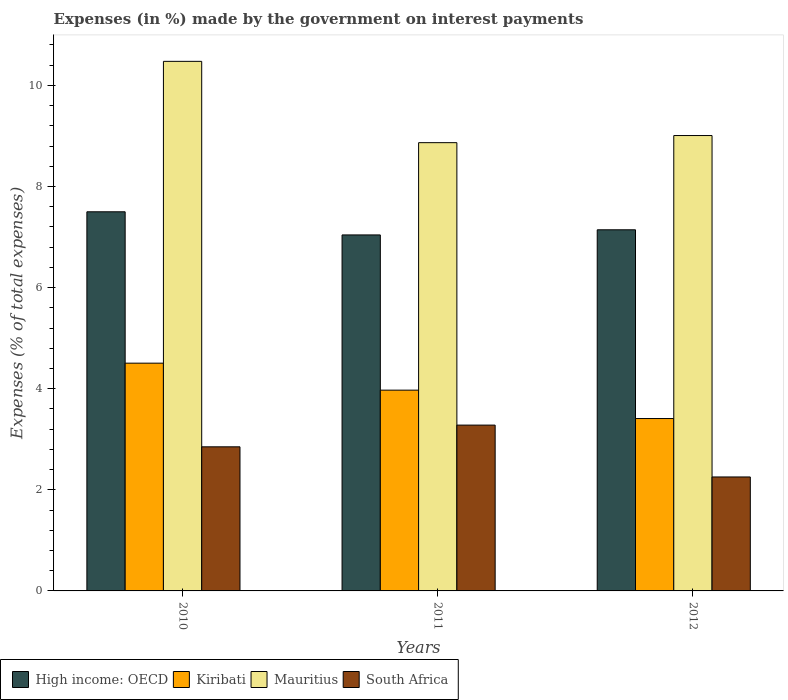What is the label of the 3rd group of bars from the left?
Your response must be concise. 2012. In how many cases, is the number of bars for a given year not equal to the number of legend labels?
Your answer should be very brief. 0. What is the percentage of expenses made by the government on interest payments in Mauritius in 2010?
Offer a very short reply. 10.48. Across all years, what is the maximum percentage of expenses made by the government on interest payments in South Africa?
Offer a very short reply. 3.28. Across all years, what is the minimum percentage of expenses made by the government on interest payments in High income: OECD?
Your answer should be compact. 7.04. In which year was the percentage of expenses made by the government on interest payments in Mauritius maximum?
Provide a short and direct response. 2010. In which year was the percentage of expenses made by the government on interest payments in High income: OECD minimum?
Provide a short and direct response. 2011. What is the total percentage of expenses made by the government on interest payments in Kiribati in the graph?
Keep it short and to the point. 11.89. What is the difference between the percentage of expenses made by the government on interest payments in Kiribati in 2011 and that in 2012?
Your answer should be very brief. 0.56. What is the difference between the percentage of expenses made by the government on interest payments in Mauritius in 2011 and the percentage of expenses made by the government on interest payments in South Africa in 2012?
Provide a succinct answer. 6.61. What is the average percentage of expenses made by the government on interest payments in Mauritius per year?
Your answer should be compact. 9.45. In the year 2012, what is the difference between the percentage of expenses made by the government on interest payments in High income: OECD and percentage of expenses made by the government on interest payments in South Africa?
Make the answer very short. 4.89. What is the ratio of the percentage of expenses made by the government on interest payments in South Africa in 2011 to that in 2012?
Keep it short and to the point. 1.46. What is the difference between the highest and the second highest percentage of expenses made by the government on interest payments in Mauritius?
Offer a very short reply. 1.47. What is the difference between the highest and the lowest percentage of expenses made by the government on interest payments in Mauritius?
Provide a short and direct response. 1.61. In how many years, is the percentage of expenses made by the government on interest payments in Mauritius greater than the average percentage of expenses made by the government on interest payments in Mauritius taken over all years?
Make the answer very short. 1. What does the 4th bar from the left in 2010 represents?
Offer a very short reply. South Africa. What does the 2nd bar from the right in 2012 represents?
Keep it short and to the point. Mauritius. Is it the case that in every year, the sum of the percentage of expenses made by the government on interest payments in Mauritius and percentage of expenses made by the government on interest payments in South Africa is greater than the percentage of expenses made by the government on interest payments in High income: OECD?
Provide a short and direct response. Yes. Are all the bars in the graph horizontal?
Ensure brevity in your answer.  No. Are the values on the major ticks of Y-axis written in scientific E-notation?
Your answer should be compact. No. Does the graph contain any zero values?
Give a very brief answer. No. How many legend labels are there?
Provide a succinct answer. 4. What is the title of the graph?
Offer a very short reply. Expenses (in %) made by the government on interest payments. What is the label or title of the X-axis?
Make the answer very short. Years. What is the label or title of the Y-axis?
Give a very brief answer. Expenses (% of total expenses). What is the Expenses (% of total expenses) of High income: OECD in 2010?
Offer a terse response. 7.5. What is the Expenses (% of total expenses) of Kiribati in 2010?
Keep it short and to the point. 4.51. What is the Expenses (% of total expenses) of Mauritius in 2010?
Provide a short and direct response. 10.48. What is the Expenses (% of total expenses) in South Africa in 2010?
Give a very brief answer. 2.85. What is the Expenses (% of total expenses) in High income: OECD in 2011?
Provide a succinct answer. 7.04. What is the Expenses (% of total expenses) in Kiribati in 2011?
Your answer should be very brief. 3.97. What is the Expenses (% of total expenses) in Mauritius in 2011?
Provide a short and direct response. 8.87. What is the Expenses (% of total expenses) of South Africa in 2011?
Provide a short and direct response. 3.28. What is the Expenses (% of total expenses) in High income: OECD in 2012?
Offer a very short reply. 7.14. What is the Expenses (% of total expenses) of Kiribati in 2012?
Your answer should be very brief. 3.41. What is the Expenses (% of total expenses) of Mauritius in 2012?
Provide a succinct answer. 9.01. What is the Expenses (% of total expenses) of South Africa in 2012?
Your answer should be very brief. 2.25. Across all years, what is the maximum Expenses (% of total expenses) of High income: OECD?
Provide a succinct answer. 7.5. Across all years, what is the maximum Expenses (% of total expenses) in Kiribati?
Give a very brief answer. 4.51. Across all years, what is the maximum Expenses (% of total expenses) in Mauritius?
Give a very brief answer. 10.48. Across all years, what is the maximum Expenses (% of total expenses) in South Africa?
Provide a short and direct response. 3.28. Across all years, what is the minimum Expenses (% of total expenses) of High income: OECD?
Provide a succinct answer. 7.04. Across all years, what is the minimum Expenses (% of total expenses) in Kiribati?
Ensure brevity in your answer.  3.41. Across all years, what is the minimum Expenses (% of total expenses) of Mauritius?
Offer a terse response. 8.87. Across all years, what is the minimum Expenses (% of total expenses) in South Africa?
Ensure brevity in your answer.  2.25. What is the total Expenses (% of total expenses) in High income: OECD in the graph?
Your answer should be very brief. 21.69. What is the total Expenses (% of total expenses) of Kiribati in the graph?
Make the answer very short. 11.89. What is the total Expenses (% of total expenses) of Mauritius in the graph?
Provide a short and direct response. 28.35. What is the total Expenses (% of total expenses) in South Africa in the graph?
Provide a short and direct response. 8.38. What is the difference between the Expenses (% of total expenses) of High income: OECD in 2010 and that in 2011?
Give a very brief answer. 0.46. What is the difference between the Expenses (% of total expenses) in Kiribati in 2010 and that in 2011?
Offer a very short reply. 0.53. What is the difference between the Expenses (% of total expenses) in Mauritius in 2010 and that in 2011?
Keep it short and to the point. 1.61. What is the difference between the Expenses (% of total expenses) of South Africa in 2010 and that in 2011?
Your answer should be very brief. -0.43. What is the difference between the Expenses (% of total expenses) of High income: OECD in 2010 and that in 2012?
Make the answer very short. 0.36. What is the difference between the Expenses (% of total expenses) in Kiribati in 2010 and that in 2012?
Your response must be concise. 1.1. What is the difference between the Expenses (% of total expenses) in Mauritius in 2010 and that in 2012?
Keep it short and to the point. 1.47. What is the difference between the Expenses (% of total expenses) in South Africa in 2010 and that in 2012?
Keep it short and to the point. 0.6. What is the difference between the Expenses (% of total expenses) in High income: OECD in 2011 and that in 2012?
Offer a very short reply. -0.1. What is the difference between the Expenses (% of total expenses) of Kiribati in 2011 and that in 2012?
Ensure brevity in your answer.  0.56. What is the difference between the Expenses (% of total expenses) of Mauritius in 2011 and that in 2012?
Give a very brief answer. -0.14. What is the difference between the Expenses (% of total expenses) of South Africa in 2011 and that in 2012?
Keep it short and to the point. 1.03. What is the difference between the Expenses (% of total expenses) in High income: OECD in 2010 and the Expenses (% of total expenses) in Kiribati in 2011?
Your response must be concise. 3.53. What is the difference between the Expenses (% of total expenses) of High income: OECD in 2010 and the Expenses (% of total expenses) of Mauritius in 2011?
Make the answer very short. -1.37. What is the difference between the Expenses (% of total expenses) of High income: OECD in 2010 and the Expenses (% of total expenses) of South Africa in 2011?
Give a very brief answer. 4.22. What is the difference between the Expenses (% of total expenses) in Kiribati in 2010 and the Expenses (% of total expenses) in Mauritius in 2011?
Ensure brevity in your answer.  -4.36. What is the difference between the Expenses (% of total expenses) of Kiribati in 2010 and the Expenses (% of total expenses) of South Africa in 2011?
Your response must be concise. 1.23. What is the difference between the Expenses (% of total expenses) in Mauritius in 2010 and the Expenses (% of total expenses) in South Africa in 2011?
Give a very brief answer. 7.2. What is the difference between the Expenses (% of total expenses) in High income: OECD in 2010 and the Expenses (% of total expenses) in Kiribati in 2012?
Provide a succinct answer. 4.09. What is the difference between the Expenses (% of total expenses) in High income: OECD in 2010 and the Expenses (% of total expenses) in Mauritius in 2012?
Keep it short and to the point. -1.51. What is the difference between the Expenses (% of total expenses) of High income: OECD in 2010 and the Expenses (% of total expenses) of South Africa in 2012?
Your answer should be very brief. 5.25. What is the difference between the Expenses (% of total expenses) of Kiribati in 2010 and the Expenses (% of total expenses) of Mauritius in 2012?
Your answer should be compact. -4.5. What is the difference between the Expenses (% of total expenses) in Kiribati in 2010 and the Expenses (% of total expenses) in South Africa in 2012?
Offer a terse response. 2.25. What is the difference between the Expenses (% of total expenses) in Mauritius in 2010 and the Expenses (% of total expenses) in South Africa in 2012?
Provide a short and direct response. 8.22. What is the difference between the Expenses (% of total expenses) in High income: OECD in 2011 and the Expenses (% of total expenses) in Kiribati in 2012?
Provide a succinct answer. 3.63. What is the difference between the Expenses (% of total expenses) in High income: OECD in 2011 and the Expenses (% of total expenses) in Mauritius in 2012?
Your answer should be compact. -1.97. What is the difference between the Expenses (% of total expenses) of High income: OECD in 2011 and the Expenses (% of total expenses) of South Africa in 2012?
Your answer should be compact. 4.79. What is the difference between the Expenses (% of total expenses) of Kiribati in 2011 and the Expenses (% of total expenses) of Mauritius in 2012?
Provide a succinct answer. -5.04. What is the difference between the Expenses (% of total expenses) of Kiribati in 2011 and the Expenses (% of total expenses) of South Africa in 2012?
Offer a very short reply. 1.72. What is the difference between the Expenses (% of total expenses) in Mauritius in 2011 and the Expenses (% of total expenses) in South Africa in 2012?
Ensure brevity in your answer.  6.61. What is the average Expenses (% of total expenses) of High income: OECD per year?
Offer a terse response. 7.23. What is the average Expenses (% of total expenses) of Kiribati per year?
Make the answer very short. 3.96. What is the average Expenses (% of total expenses) of Mauritius per year?
Offer a very short reply. 9.45. What is the average Expenses (% of total expenses) in South Africa per year?
Offer a very short reply. 2.79. In the year 2010, what is the difference between the Expenses (% of total expenses) of High income: OECD and Expenses (% of total expenses) of Kiribati?
Ensure brevity in your answer.  2.99. In the year 2010, what is the difference between the Expenses (% of total expenses) of High income: OECD and Expenses (% of total expenses) of Mauritius?
Your response must be concise. -2.98. In the year 2010, what is the difference between the Expenses (% of total expenses) of High income: OECD and Expenses (% of total expenses) of South Africa?
Your answer should be compact. 4.65. In the year 2010, what is the difference between the Expenses (% of total expenses) in Kiribati and Expenses (% of total expenses) in Mauritius?
Give a very brief answer. -5.97. In the year 2010, what is the difference between the Expenses (% of total expenses) in Kiribati and Expenses (% of total expenses) in South Africa?
Provide a succinct answer. 1.65. In the year 2010, what is the difference between the Expenses (% of total expenses) in Mauritius and Expenses (% of total expenses) in South Africa?
Offer a very short reply. 7.62. In the year 2011, what is the difference between the Expenses (% of total expenses) in High income: OECD and Expenses (% of total expenses) in Kiribati?
Your answer should be very brief. 3.07. In the year 2011, what is the difference between the Expenses (% of total expenses) in High income: OECD and Expenses (% of total expenses) in Mauritius?
Your answer should be compact. -1.82. In the year 2011, what is the difference between the Expenses (% of total expenses) in High income: OECD and Expenses (% of total expenses) in South Africa?
Your response must be concise. 3.76. In the year 2011, what is the difference between the Expenses (% of total expenses) of Kiribati and Expenses (% of total expenses) of Mauritius?
Your response must be concise. -4.9. In the year 2011, what is the difference between the Expenses (% of total expenses) of Kiribati and Expenses (% of total expenses) of South Africa?
Your answer should be compact. 0.69. In the year 2011, what is the difference between the Expenses (% of total expenses) in Mauritius and Expenses (% of total expenses) in South Africa?
Give a very brief answer. 5.59. In the year 2012, what is the difference between the Expenses (% of total expenses) in High income: OECD and Expenses (% of total expenses) in Kiribati?
Make the answer very short. 3.73. In the year 2012, what is the difference between the Expenses (% of total expenses) of High income: OECD and Expenses (% of total expenses) of Mauritius?
Provide a short and direct response. -1.86. In the year 2012, what is the difference between the Expenses (% of total expenses) in High income: OECD and Expenses (% of total expenses) in South Africa?
Your response must be concise. 4.89. In the year 2012, what is the difference between the Expenses (% of total expenses) of Kiribati and Expenses (% of total expenses) of Mauritius?
Offer a very short reply. -5.6. In the year 2012, what is the difference between the Expenses (% of total expenses) of Kiribati and Expenses (% of total expenses) of South Africa?
Give a very brief answer. 1.16. In the year 2012, what is the difference between the Expenses (% of total expenses) in Mauritius and Expenses (% of total expenses) in South Africa?
Give a very brief answer. 6.75. What is the ratio of the Expenses (% of total expenses) of High income: OECD in 2010 to that in 2011?
Offer a very short reply. 1.06. What is the ratio of the Expenses (% of total expenses) in Kiribati in 2010 to that in 2011?
Your response must be concise. 1.13. What is the ratio of the Expenses (% of total expenses) of Mauritius in 2010 to that in 2011?
Your answer should be very brief. 1.18. What is the ratio of the Expenses (% of total expenses) in South Africa in 2010 to that in 2011?
Give a very brief answer. 0.87. What is the ratio of the Expenses (% of total expenses) of High income: OECD in 2010 to that in 2012?
Your response must be concise. 1.05. What is the ratio of the Expenses (% of total expenses) of Kiribati in 2010 to that in 2012?
Ensure brevity in your answer.  1.32. What is the ratio of the Expenses (% of total expenses) of Mauritius in 2010 to that in 2012?
Offer a terse response. 1.16. What is the ratio of the Expenses (% of total expenses) in South Africa in 2010 to that in 2012?
Offer a very short reply. 1.26. What is the ratio of the Expenses (% of total expenses) in High income: OECD in 2011 to that in 2012?
Offer a very short reply. 0.99. What is the ratio of the Expenses (% of total expenses) of Kiribati in 2011 to that in 2012?
Your response must be concise. 1.16. What is the ratio of the Expenses (% of total expenses) in Mauritius in 2011 to that in 2012?
Your answer should be compact. 0.98. What is the ratio of the Expenses (% of total expenses) in South Africa in 2011 to that in 2012?
Provide a short and direct response. 1.46. What is the difference between the highest and the second highest Expenses (% of total expenses) in High income: OECD?
Your response must be concise. 0.36. What is the difference between the highest and the second highest Expenses (% of total expenses) of Kiribati?
Your answer should be very brief. 0.53. What is the difference between the highest and the second highest Expenses (% of total expenses) in Mauritius?
Your answer should be very brief. 1.47. What is the difference between the highest and the second highest Expenses (% of total expenses) of South Africa?
Keep it short and to the point. 0.43. What is the difference between the highest and the lowest Expenses (% of total expenses) in High income: OECD?
Make the answer very short. 0.46. What is the difference between the highest and the lowest Expenses (% of total expenses) in Kiribati?
Your answer should be very brief. 1.1. What is the difference between the highest and the lowest Expenses (% of total expenses) in Mauritius?
Offer a terse response. 1.61. What is the difference between the highest and the lowest Expenses (% of total expenses) in South Africa?
Offer a very short reply. 1.03. 